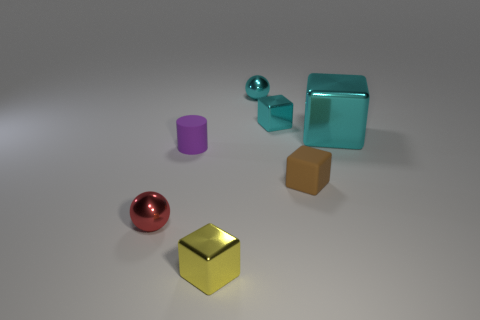Subtract all shiny cubes. How many cubes are left? 1 Add 3 small cylinders. How many objects exist? 10 Subtract all cyan blocks. How many blocks are left? 2 Subtract all brown spheres. How many cyan cubes are left? 2 Subtract all tiny cyan metallic blocks. Subtract all purple rubber things. How many objects are left? 5 Add 3 tiny purple matte cylinders. How many tiny purple matte cylinders are left? 4 Add 4 small cylinders. How many small cylinders exist? 5 Subtract 1 yellow cubes. How many objects are left? 6 Subtract all balls. How many objects are left? 5 Subtract 1 cylinders. How many cylinders are left? 0 